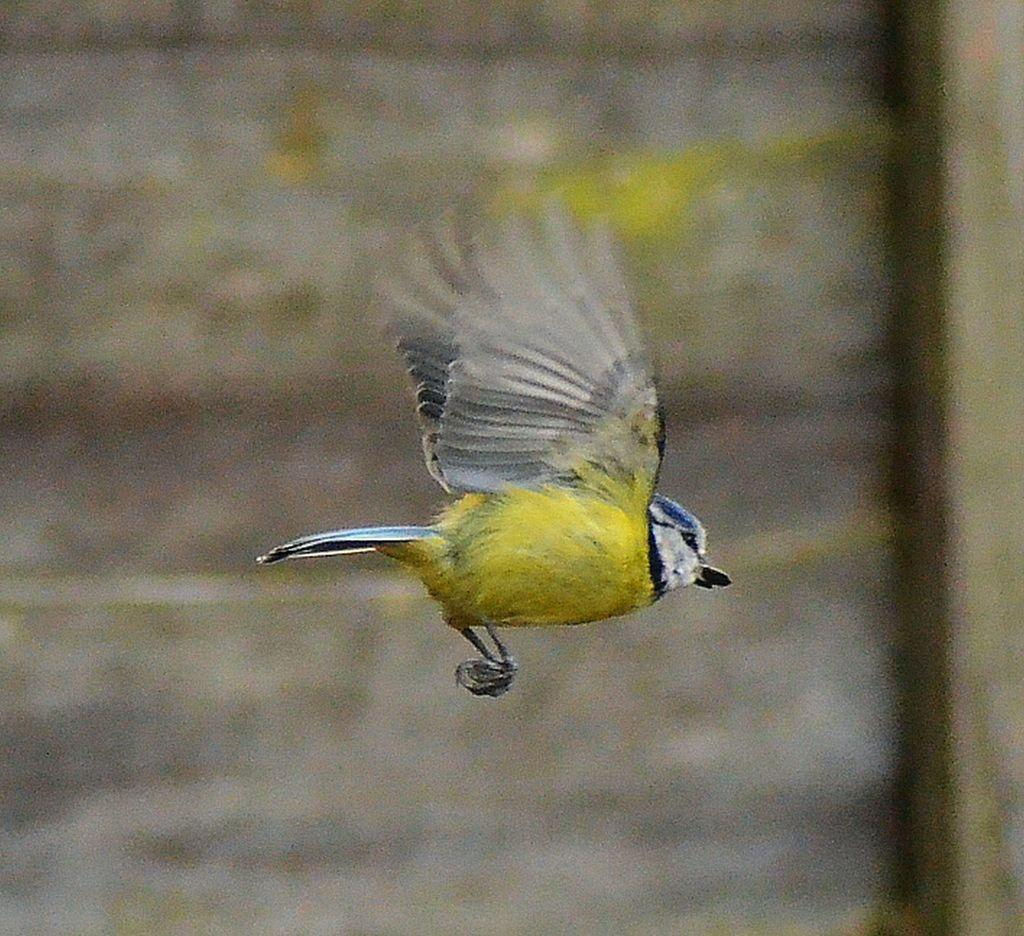What is the main subject of the image? A bird is flying in the image. Can you describe the background of the image? The background of the image is blurred. What type of pest can be seen in the image? There is no pest present in the image; it features a bird flying. What is the bird doing to unlock the door in the image? There is no door or lock present in the image, and the bird is simply flying. 